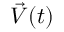Convert formula to latex. <formula><loc_0><loc_0><loc_500><loc_500>\vec { V } ( t )</formula> 